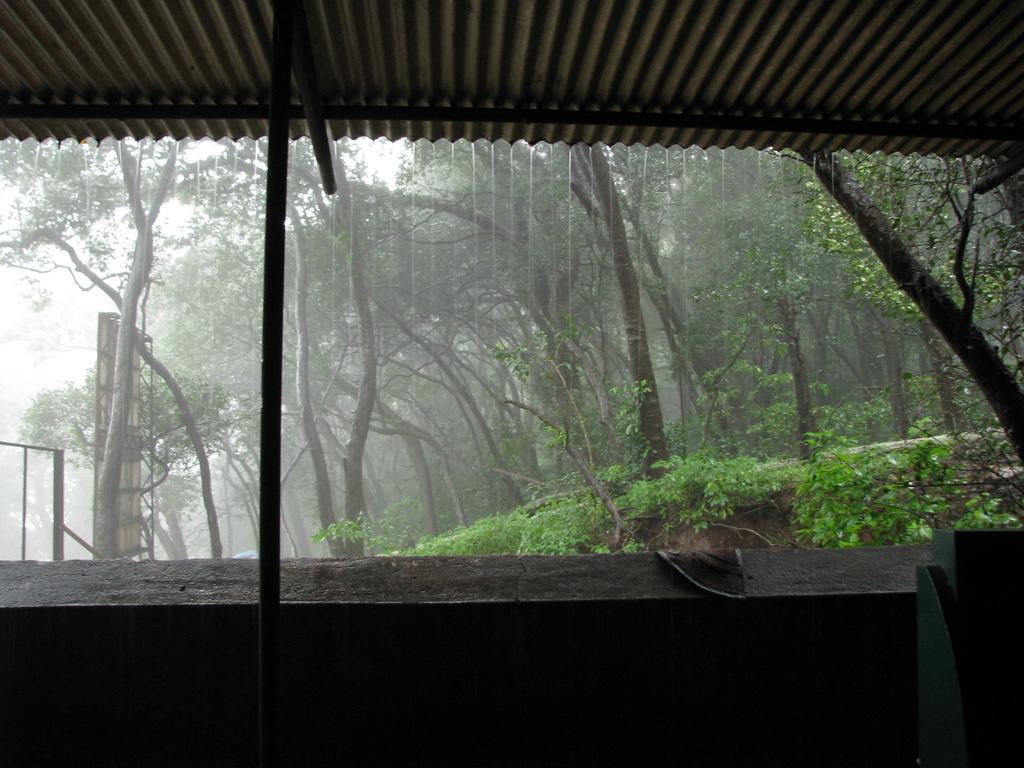What type of structure is present in the image? There is a shed in the image. What type of natural elements can be seen in the image? There are trees and plants in the image. What man-made objects are present in the image? There are poles in the image. What is the weather like in the image? It is raining in the image. Where is the bedroom located in the image? There is no bedroom present in the image. What is the height of the plants in the image? The height of the plants cannot be determined from the image alone. 